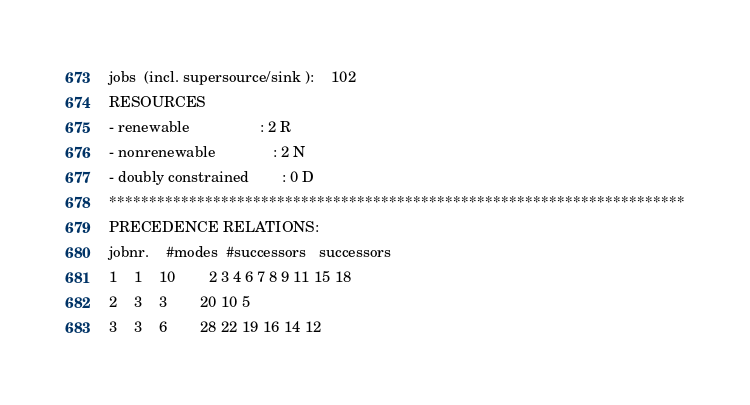<code> <loc_0><loc_0><loc_500><loc_500><_ObjectiveC_>jobs  (incl. supersource/sink ):	102
RESOURCES
- renewable                 : 2 R
- nonrenewable              : 2 N
- doubly constrained        : 0 D
************************************************************************
PRECEDENCE RELATIONS:
jobnr.    #modes  #successors   successors
1	1	10		2 3 4 6 7 8 9 11 15 18 
2	3	3		20 10 5 
3	3	6		28 22 19 16 14 12 </code> 